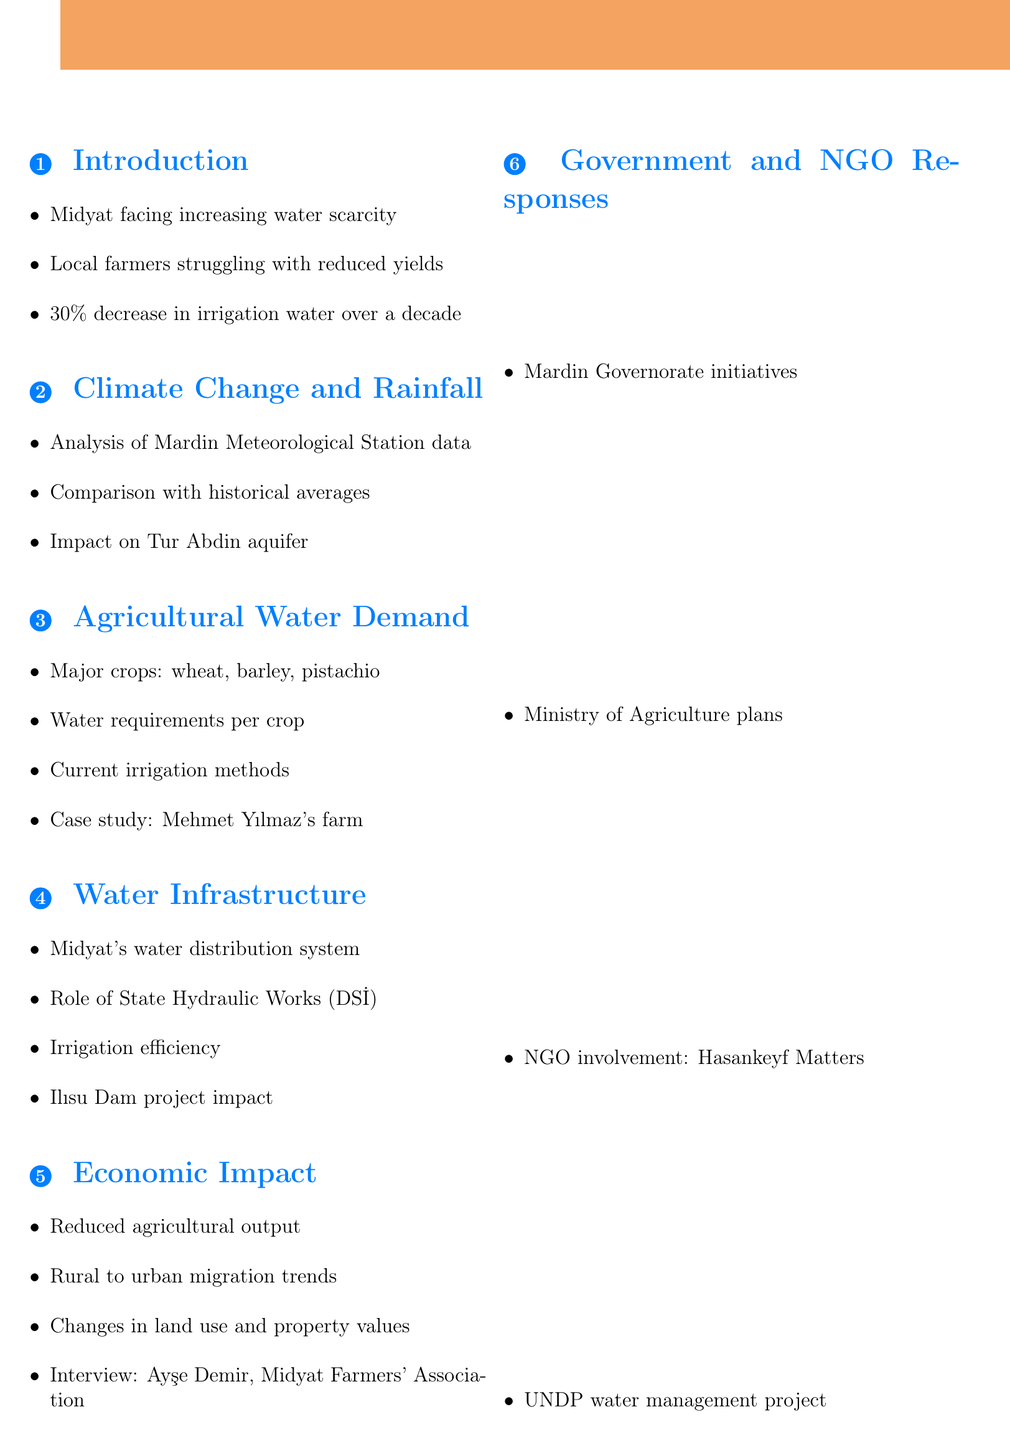What is the title of the report? The title of the report is the first line presented in the document.
Answer: Water Scarcity in Midyat: A Threat to Agricultural Sustainability What percentage has water availability for irrigation decreased? The document specifies the key statistic about the decrease in water availability.
Answer: 30% Who is the head of the Midyat Farmers' Association? The document mentions this individual in the section about Economic Impact on Local Communities.
Answer: Ayşe Demir What major crop requires water in Midyat? The report lists major crops under the Agricultural Water Demand section.
Answer: Wheat What is one of the proposed solutions for water scarcity? The conclusion section provides potential solutions to address the issue.
Answer: Rainwater harvesting Which expert is a Hydrologist at Mardin Artuklu University? The expert interviews section provides the titles and affiliations of experts consulted.
Answer: Dr. Leyla Aksoy What is the role of the State Hydraulic Works (DSİ)? The document mentions this entity in reference to water management strategies.
Answer: Water management What kind of map is included in the data visualization? The document specifies a visual representation included in the findings.
Answer: Map of Midyat showing major agricultural areas and water sources 